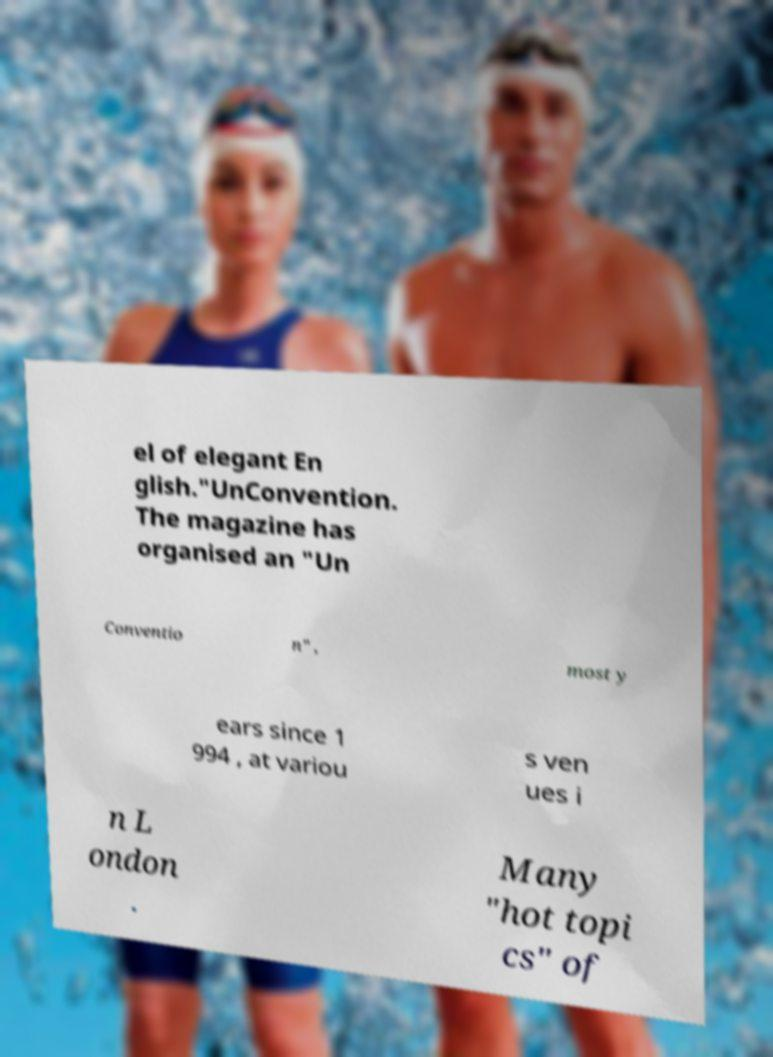I need the written content from this picture converted into text. Can you do that? el of elegant En glish."UnConvention. The magazine has organised an "Un Conventio n" , most y ears since 1 994 , at variou s ven ues i n L ondon . Many "hot topi cs" of 